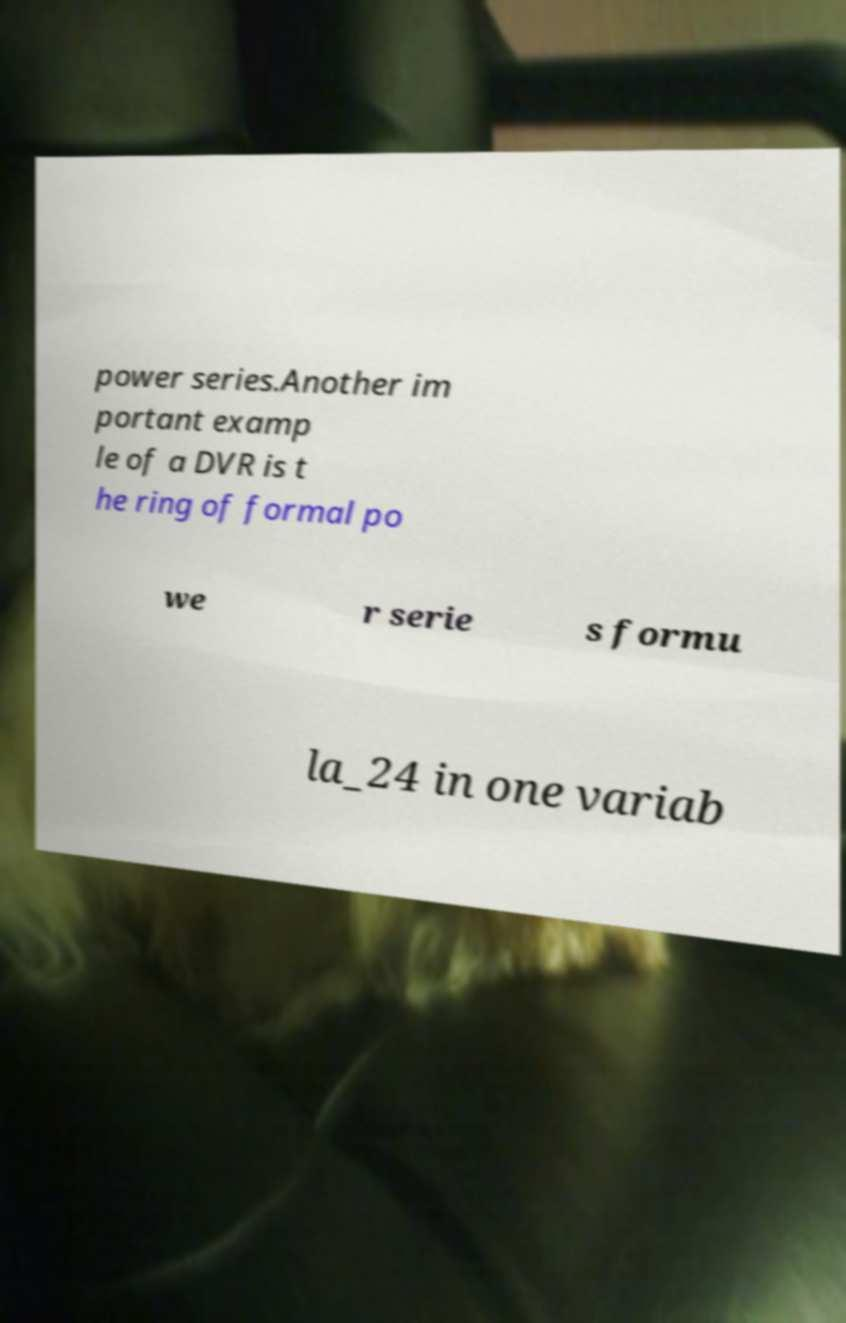Could you extract and type out the text from this image? power series.Another im portant examp le of a DVR is t he ring of formal po we r serie s formu la_24 in one variab 